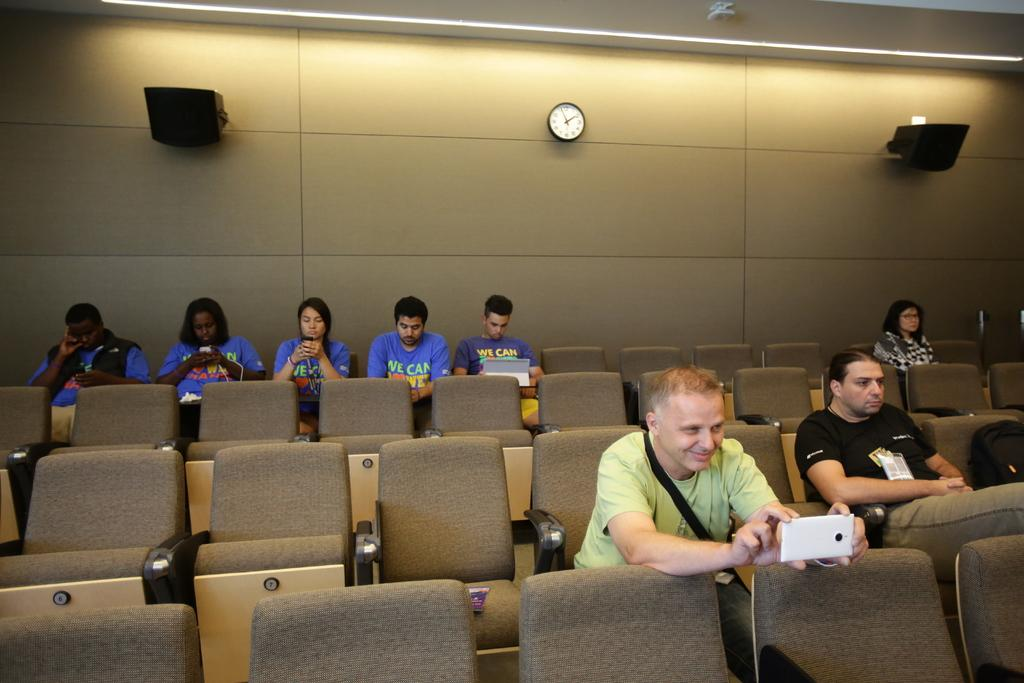<image>
Give a short and clear explanation of the subsequent image. a hall with people in blue shirts that say we can 